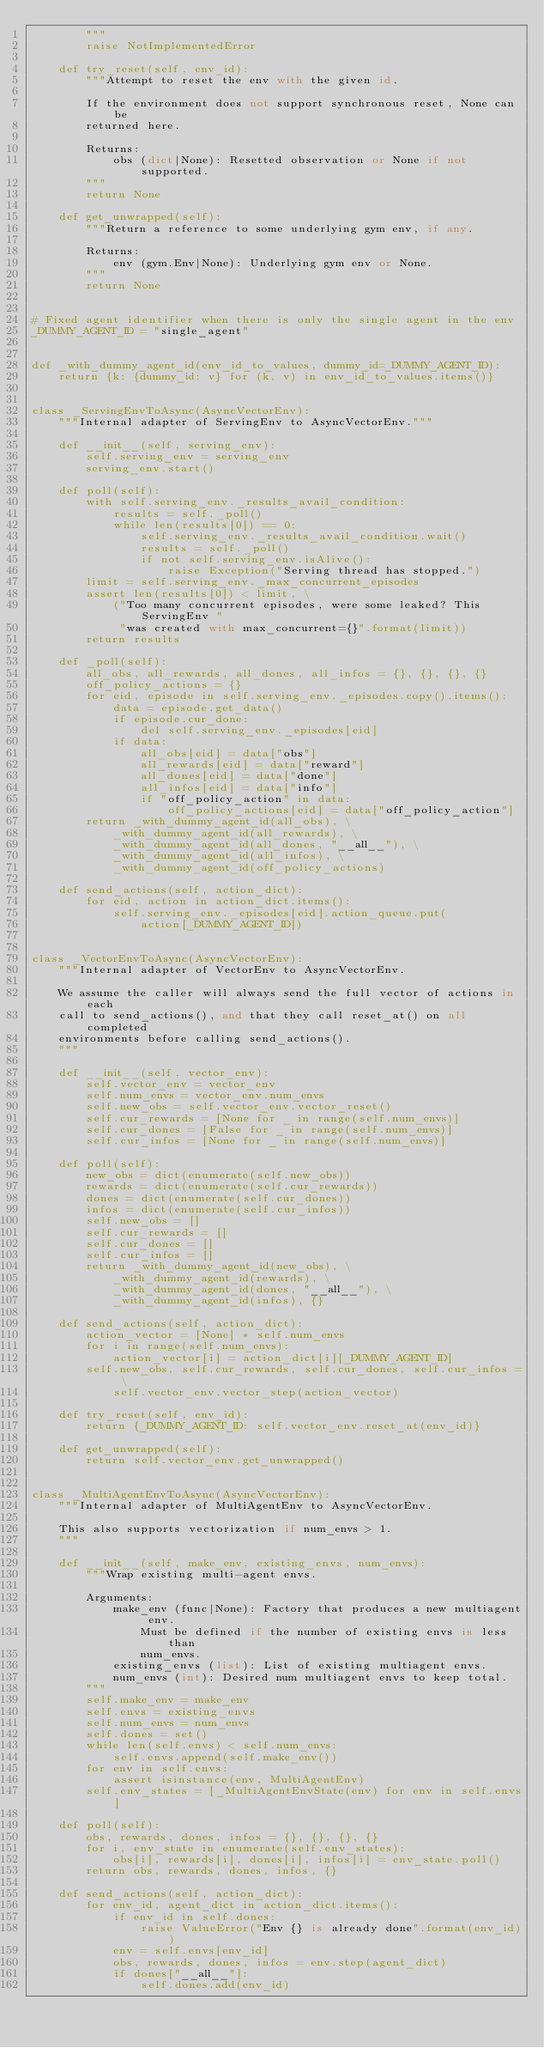Convert code to text. <code><loc_0><loc_0><loc_500><loc_500><_Python_>        """
        raise NotImplementedError

    def try_reset(self, env_id):
        """Attempt to reset the env with the given id.

        If the environment does not support synchronous reset, None can be
        returned here.

        Returns:
            obs (dict|None): Resetted observation or None if not supported.
        """
        return None

    def get_unwrapped(self):
        """Return a reference to some underlying gym env, if any.

        Returns:
            env (gym.Env|None): Underlying gym env or None.
        """
        return None


# Fixed agent identifier when there is only the single agent in the env
_DUMMY_AGENT_ID = "single_agent"


def _with_dummy_agent_id(env_id_to_values, dummy_id=_DUMMY_AGENT_ID):
    return {k: {dummy_id: v} for (k, v) in env_id_to_values.items()}


class _ServingEnvToAsync(AsyncVectorEnv):
    """Internal adapter of ServingEnv to AsyncVectorEnv."""

    def __init__(self, serving_env):
        self.serving_env = serving_env
        serving_env.start()

    def poll(self):
        with self.serving_env._results_avail_condition:
            results = self._poll()
            while len(results[0]) == 0:
                self.serving_env._results_avail_condition.wait()
                results = self._poll()
                if not self.serving_env.isAlive():
                    raise Exception("Serving thread has stopped.")
        limit = self.serving_env._max_concurrent_episodes
        assert len(results[0]) < limit, \
            ("Too many concurrent episodes, were some leaked? This ServingEnv "
             "was created with max_concurrent={}".format(limit))
        return results

    def _poll(self):
        all_obs, all_rewards, all_dones, all_infos = {}, {}, {}, {}
        off_policy_actions = {}
        for eid, episode in self.serving_env._episodes.copy().items():
            data = episode.get_data()
            if episode.cur_done:
                del self.serving_env._episodes[eid]
            if data:
                all_obs[eid] = data["obs"]
                all_rewards[eid] = data["reward"]
                all_dones[eid] = data["done"]
                all_infos[eid] = data["info"]
                if "off_policy_action" in data:
                    off_policy_actions[eid] = data["off_policy_action"]
        return _with_dummy_agent_id(all_obs), \
            _with_dummy_agent_id(all_rewards), \
            _with_dummy_agent_id(all_dones, "__all__"), \
            _with_dummy_agent_id(all_infos), \
            _with_dummy_agent_id(off_policy_actions)

    def send_actions(self, action_dict):
        for eid, action in action_dict.items():
            self.serving_env._episodes[eid].action_queue.put(
                action[_DUMMY_AGENT_ID])


class _VectorEnvToAsync(AsyncVectorEnv):
    """Internal adapter of VectorEnv to AsyncVectorEnv.

    We assume the caller will always send the full vector of actions in each
    call to send_actions(), and that they call reset_at() on all completed
    environments before calling send_actions().
    """

    def __init__(self, vector_env):
        self.vector_env = vector_env
        self.num_envs = vector_env.num_envs
        self.new_obs = self.vector_env.vector_reset()
        self.cur_rewards = [None for _ in range(self.num_envs)]
        self.cur_dones = [False for _ in range(self.num_envs)]
        self.cur_infos = [None for _ in range(self.num_envs)]

    def poll(self):
        new_obs = dict(enumerate(self.new_obs))
        rewards = dict(enumerate(self.cur_rewards))
        dones = dict(enumerate(self.cur_dones))
        infos = dict(enumerate(self.cur_infos))
        self.new_obs = []
        self.cur_rewards = []
        self.cur_dones = []
        self.cur_infos = []
        return _with_dummy_agent_id(new_obs), \
            _with_dummy_agent_id(rewards), \
            _with_dummy_agent_id(dones, "__all__"), \
            _with_dummy_agent_id(infos), {}

    def send_actions(self, action_dict):
        action_vector = [None] * self.num_envs
        for i in range(self.num_envs):
            action_vector[i] = action_dict[i][_DUMMY_AGENT_ID]
        self.new_obs, self.cur_rewards, self.cur_dones, self.cur_infos = \
            self.vector_env.vector_step(action_vector)

    def try_reset(self, env_id):
        return {_DUMMY_AGENT_ID: self.vector_env.reset_at(env_id)}

    def get_unwrapped(self):
        return self.vector_env.get_unwrapped()


class _MultiAgentEnvToAsync(AsyncVectorEnv):
    """Internal adapter of MultiAgentEnv to AsyncVectorEnv.

    This also supports vectorization if num_envs > 1.
    """

    def __init__(self, make_env, existing_envs, num_envs):
        """Wrap existing multi-agent envs.

        Arguments:
            make_env (func|None): Factory that produces a new multiagent env.
                Must be defined if the number of existing envs is less than
                num_envs.
            existing_envs (list): List of existing multiagent envs.
            num_envs (int): Desired num multiagent envs to keep total.
        """
        self.make_env = make_env
        self.envs = existing_envs
        self.num_envs = num_envs
        self.dones = set()
        while len(self.envs) < self.num_envs:
            self.envs.append(self.make_env())
        for env in self.envs:
            assert isinstance(env, MultiAgentEnv)
        self.env_states = [_MultiAgentEnvState(env) for env in self.envs]

    def poll(self):
        obs, rewards, dones, infos = {}, {}, {}, {}
        for i, env_state in enumerate(self.env_states):
            obs[i], rewards[i], dones[i], infos[i] = env_state.poll()
        return obs, rewards, dones, infos, {}

    def send_actions(self, action_dict):
        for env_id, agent_dict in action_dict.items():
            if env_id in self.dones:
                raise ValueError("Env {} is already done".format(env_id))
            env = self.envs[env_id]
            obs, rewards, dones, infos = env.step(agent_dict)
            if dones["__all__"]:
                self.dones.add(env_id)</code> 